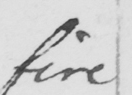Please transcribe the handwritten text in this image. fire 